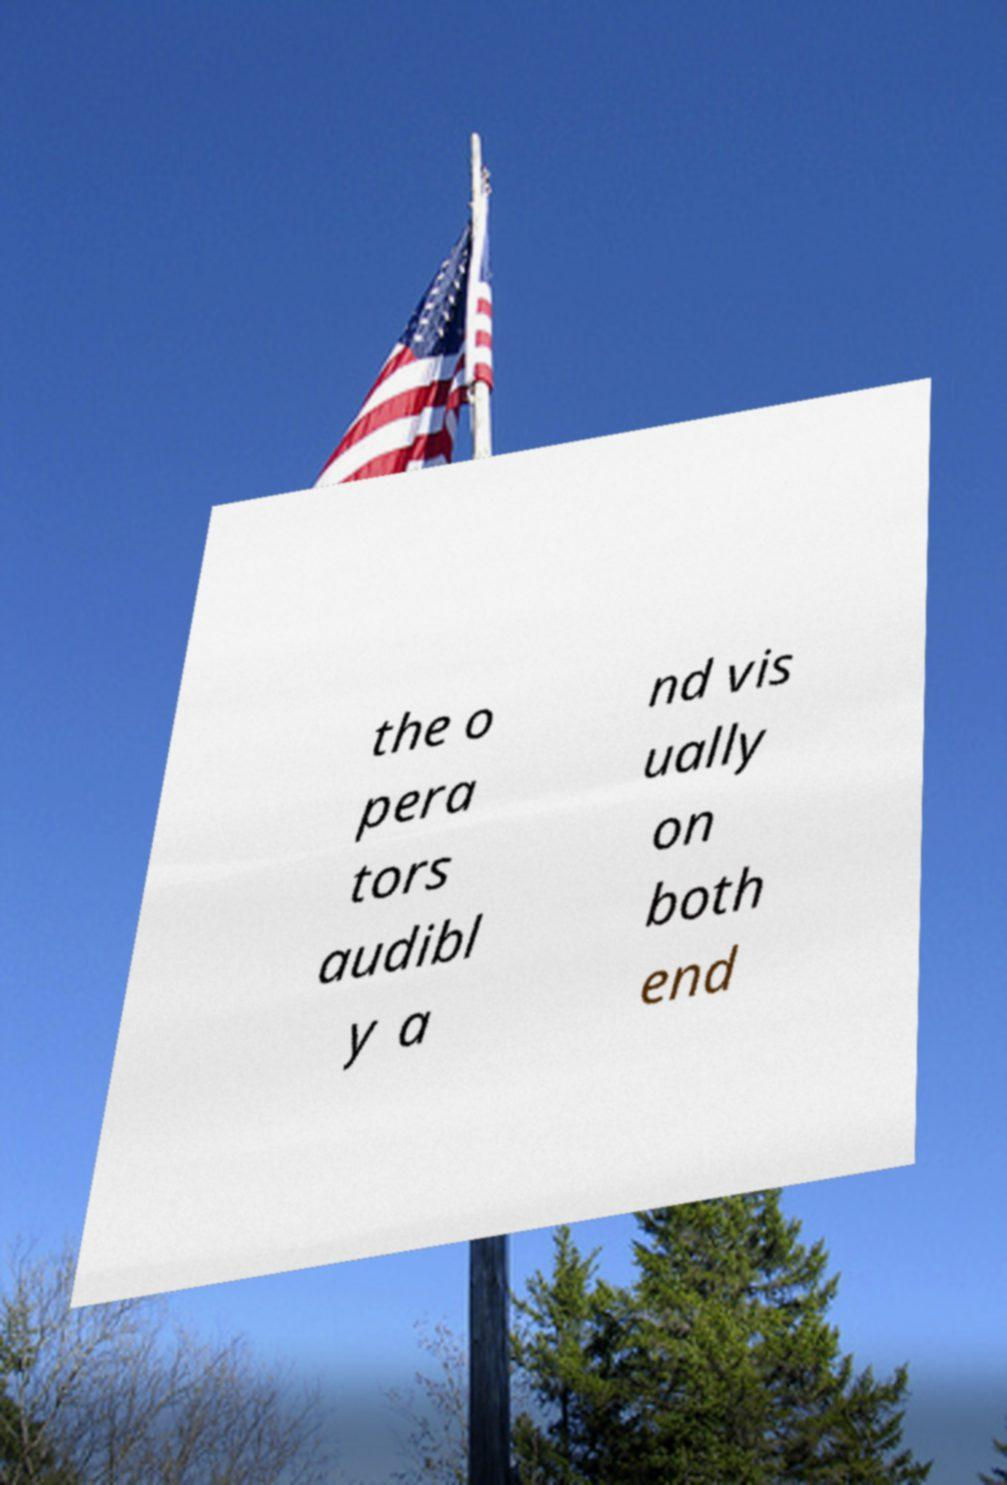Could you assist in decoding the text presented in this image and type it out clearly? the o pera tors audibl y a nd vis ually on both end 